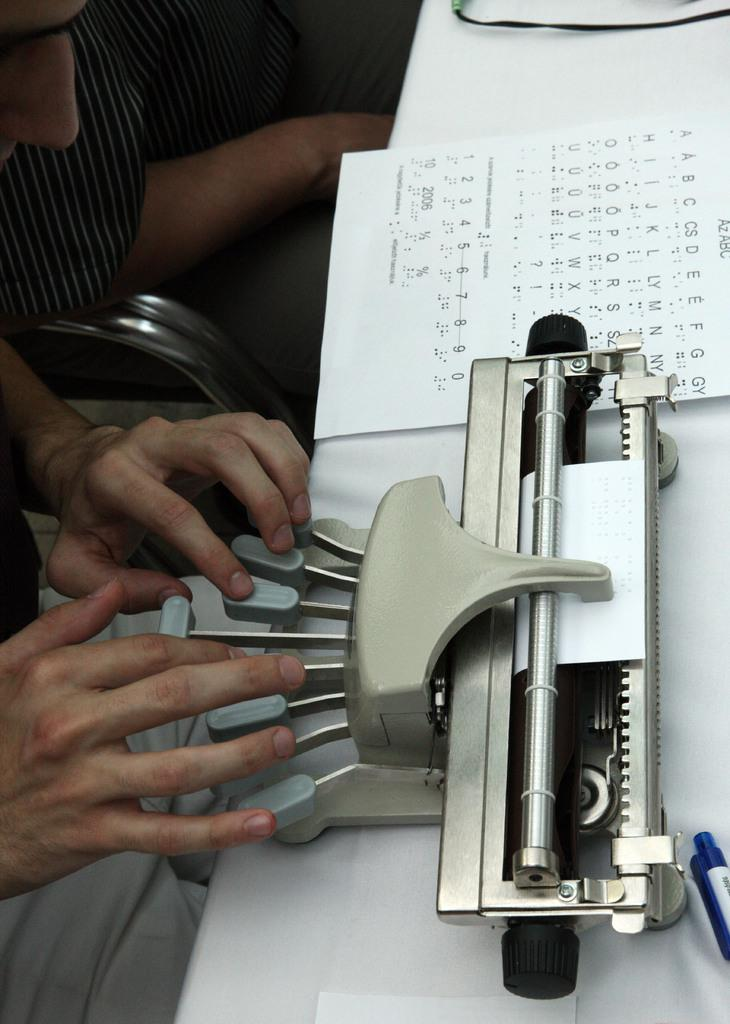What piece of furniture is present in the image? There is a table in the image. What object is placed on the table? There is a typing machine on the table. What else can be seen on the table? There is a paper and a pen on the table. Who is present in the image? There are people sitting in the image. What is the man sitting in the front doing? The man sitting in the front is typing. Can you see any chickens in the image? There are no chickens present in the image. What color is the sky in the image? The provided facts do not mention the sky, so we cannot determine its color from the image. 